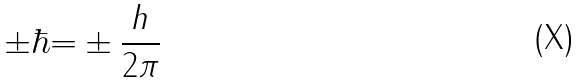Convert formula to latex. <formula><loc_0><loc_0><loc_500><loc_500>\pm \hbar { = } \pm \frac { h } { 2 \pi }</formula> 